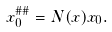<formula> <loc_0><loc_0><loc_500><loc_500>x _ { 0 } ^ { \# \# } & = N ( x ) x _ { 0 } .</formula> 